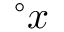Convert formula to latex. <formula><loc_0><loc_0><loc_500><loc_500>{ } ^ { \circ } x</formula> 